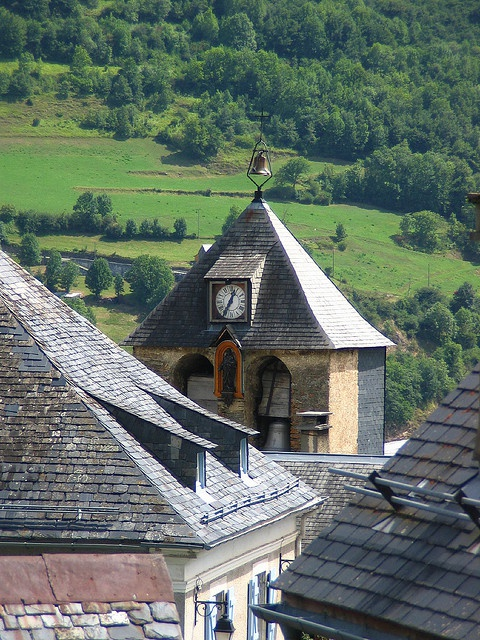Describe the objects in this image and their specific colors. I can see a clock in darkblue, darkgray, black, gray, and navy tones in this image. 